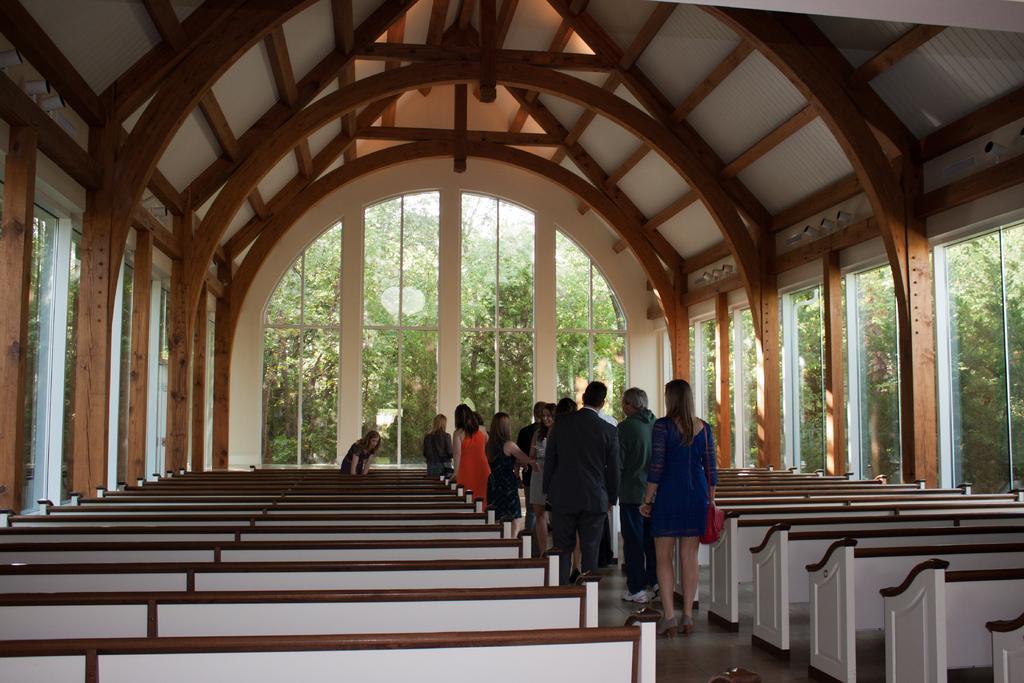Please provide a concise description of this image. In a hall there are many empty benches and in between the benches, a group of people are standing and around them there are many windows to the hall and behind the windows there are plenty of trees. 